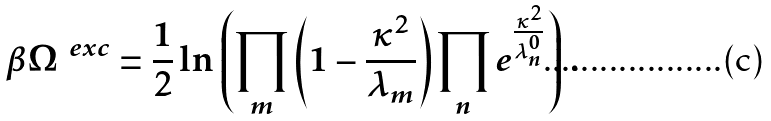Convert formula to latex. <formula><loc_0><loc_0><loc_500><loc_500>\beta \Omega ^ { \ e x c } = \frac { 1 } { 2 } \ln \left ( \prod _ { m } \left ( 1 - \frac { \kappa ^ { 2 } } { \lambda _ { m } } \right ) \prod _ { n } e ^ { \frac { \kappa ^ { 2 } } { \lambda _ { n } ^ { 0 } } } \right ) \, .</formula> 